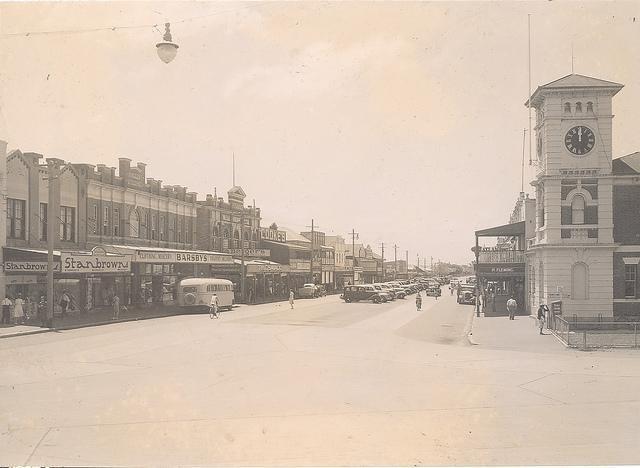How many birds are the same color?
Give a very brief answer. 0. 